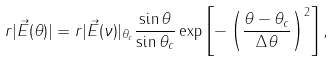Convert formula to latex. <formula><loc_0><loc_0><loc_500><loc_500>r | { \vec { E } ( \theta ) } | = r | { \vec { E } ( \nu ) } | _ { \theta _ { c } } \frac { \sin \theta } { \sin \theta _ { c } } \exp \left [ - \left ( \frac { \theta - \theta _ { c } } { \Delta \theta } \right ) ^ { 2 } \right ] ,</formula> 